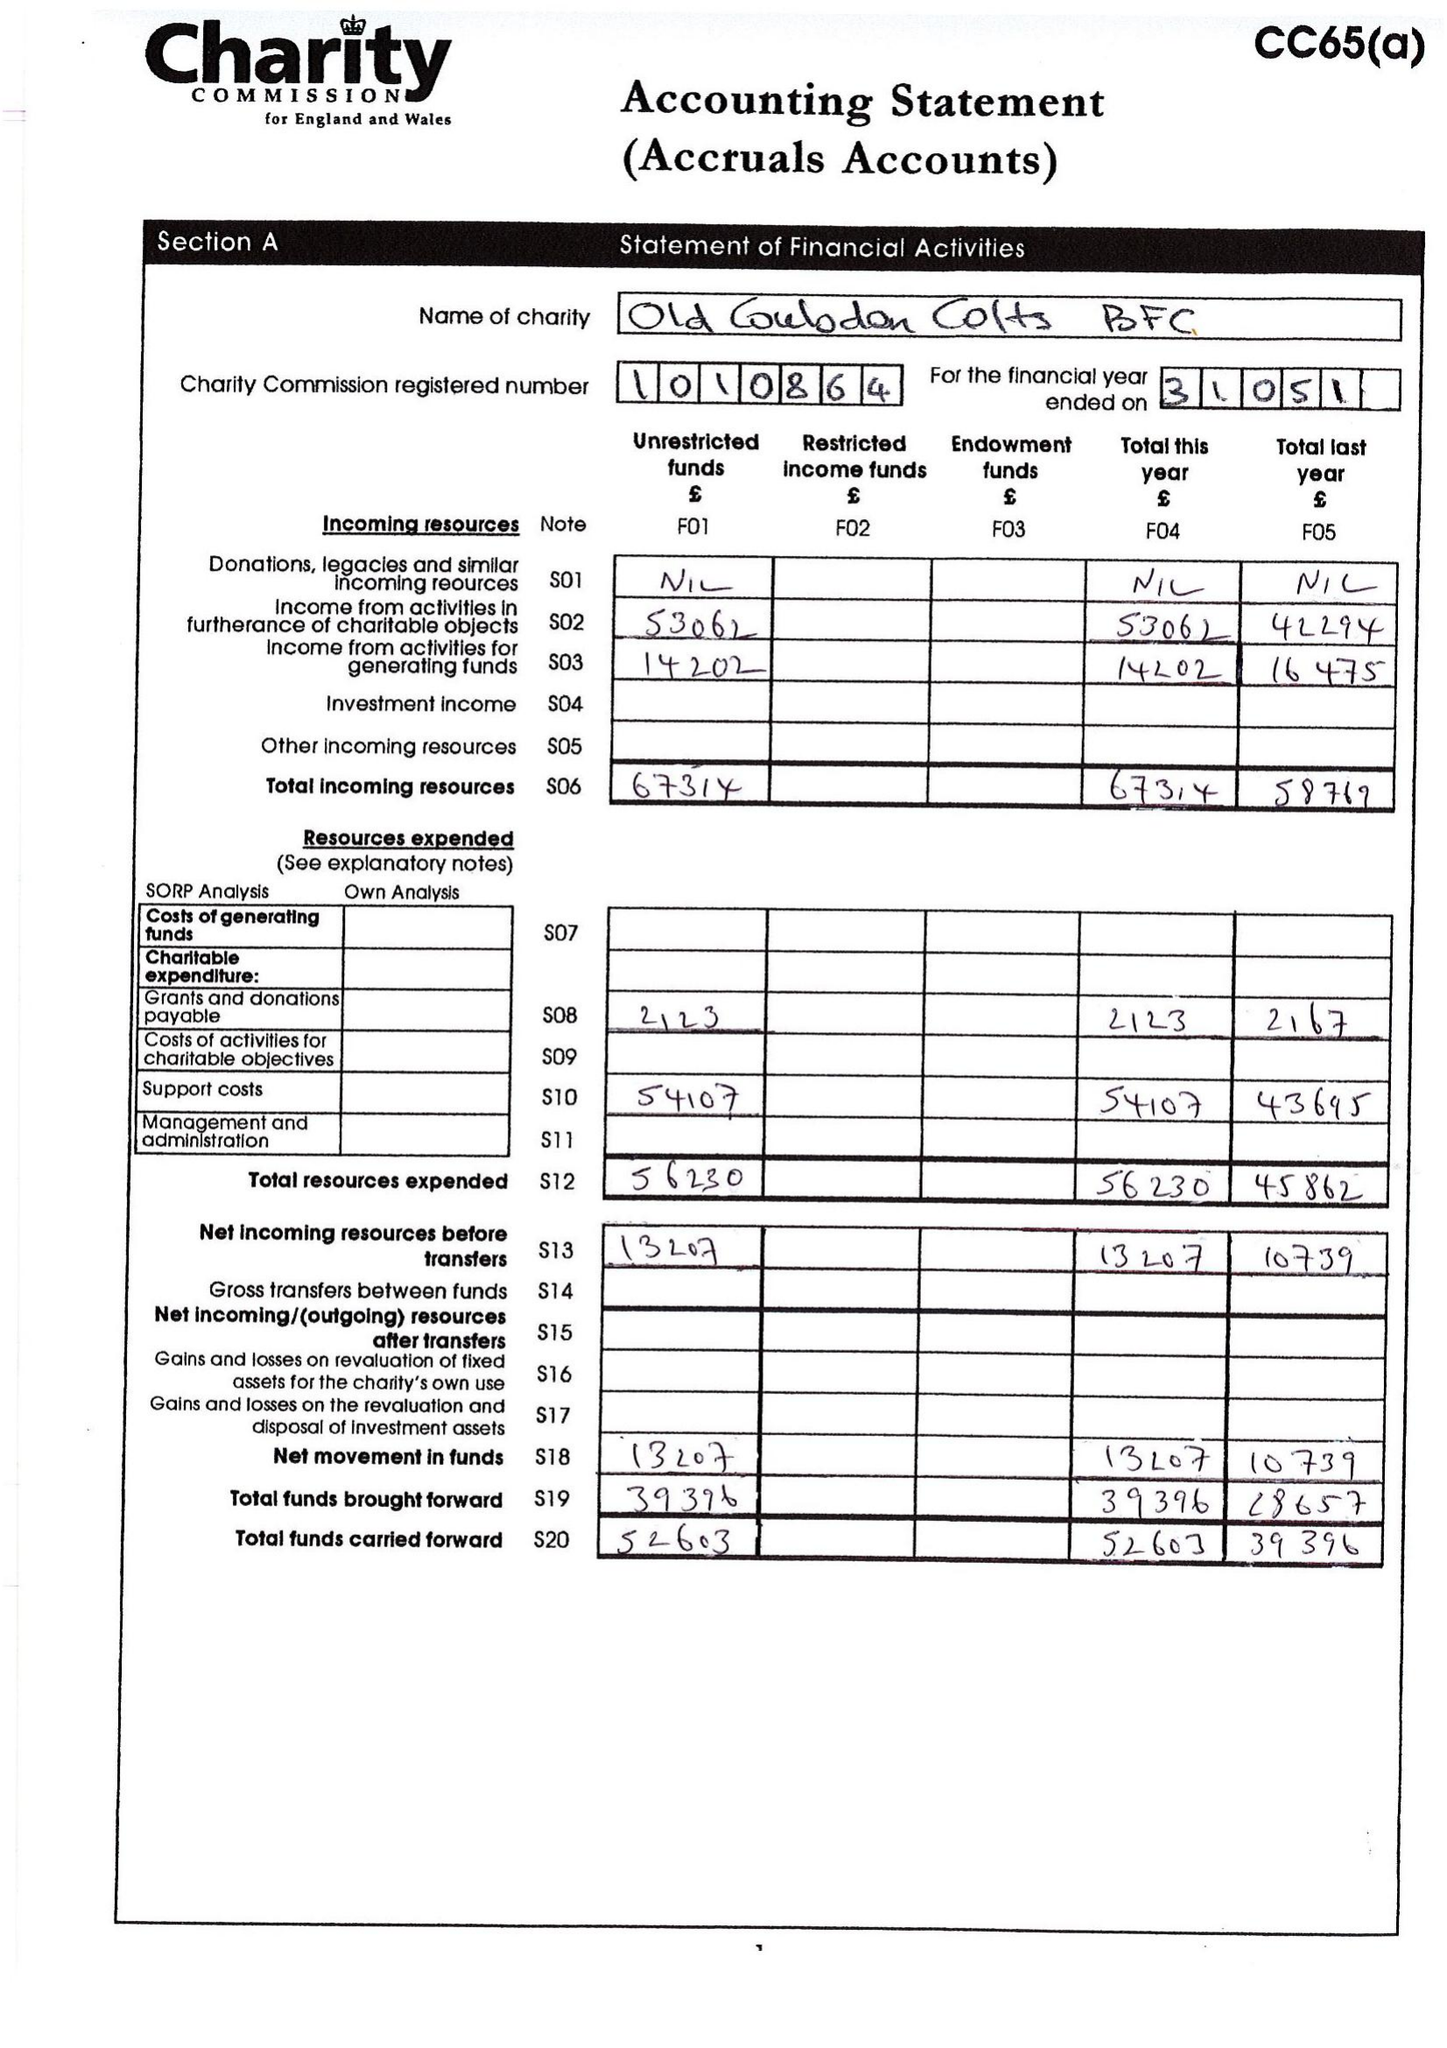What is the value for the income_annually_in_british_pounds?
Answer the question using a single word or phrase. 67314.32 